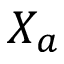<formula> <loc_0><loc_0><loc_500><loc_500>X _ { a }</formula> 